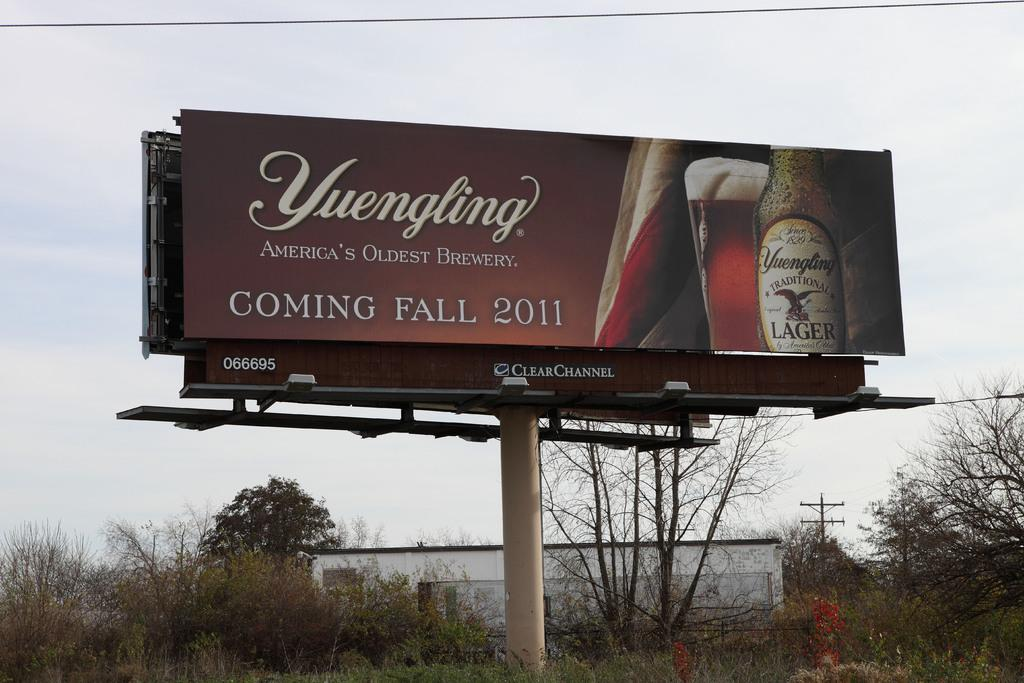<image>
Write a terse but informative summary of the picture. a billboard advertising Yuengling lager beer made in America 